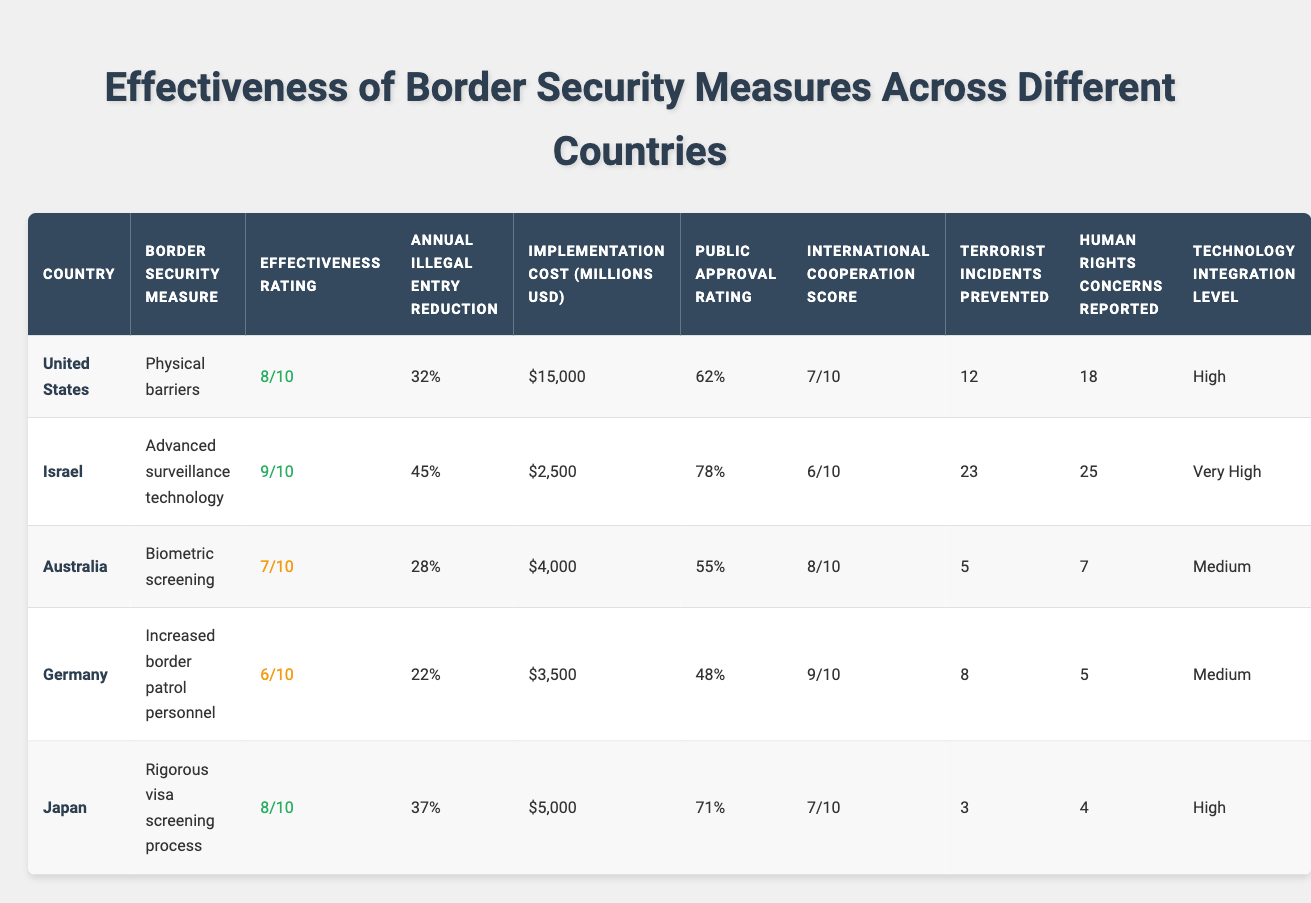What is the effectiveness rating for Israel? The effectiveness rating for Israel is listed under the "Effectiveness Rating" column for the row corresponding to Israel. The value is 9.
Answer: 9 Which country had the highest public approval rating? The public approval ratings are compared across the countries in the table. Israel has the highest value at 78%.
Answer: 78% What is the average annual illegal entry reduction across all countries? By adding the percentages of annual illegal entry reduction: 32% + 45% + 28% + 22% + 37% = 164%. Then, divide by the number of countries (5): 164% / 5 = 32.8%.
Answer: 32.8% True or False: Germany has implemented biometric screening as a border security measure. By checking the "Border Security Measure" column for Germany, it is clear that Germany has not implemented biometric screening specifically.
Answer: False Which country has the lowest number of terrorist incidents prevented, and what is that number? The number of terrorist incidents prevented can be seen in the respective column. Japan has the lowest number at 3 incidents.
Answer: Japan, 3 What is the implementation cost for border security measures in the United States, and how does it compare to the costs in Germany and Japan combined? The implementation cost for the United States is $15,000 million. Germany's cost is $3,500 million and Japan's is $5,000 million. The combined cost of Germany and Japan is $8,500 million. Comparing, the U.S. cost is significantly higher at $15,000 million.
Answer: $15,000 million, higher Which country has the highest international cooperation score, and what is that score? The "International Cooperation Score" column indicates that Germany has the highest score at 9.
Answer: Germany, 9 How many more human rights concerns were reported in Israel than in Japan? To find the difference, subtract the number of human rights concerns reported for Japan (4) from those reported for Israel (25): 25 - 4 = 21.
Answer: 21 If Australia's effectiveness rating were to increase by 2 points, how would it then compare with the effectiveness rating of Germany? Australia's effectiveness rating is currently 7. If it increases by 2 points, it would be 9. Germany's rating is 6. Therefore, Australia's adjusted rating would be higher than Germany's rating.
Answer: Higher What is the relationship between the technology integration level and the effectiveness ratings for the countries listed? Examining the "Technology Integration Level" against the "Effectiveness Rating" shows that the levels are generally high among countries with higher ratings, revealing a positive relationship.
Answer: Positive relationship If we categorize the effectiveness ratings into low, medium, and high, how many countries fall into each category? The ratings classify as follows: High (9 - Israel, 8 - U.S. & Japan): 3 countries; Medium (7 - Australia): 1 country; Low (6 - Germany): 1 country. The totals are: High: 3, Medium: 1, Low: 1.
Answer: High: 3, Medium: 1, Low: 1 